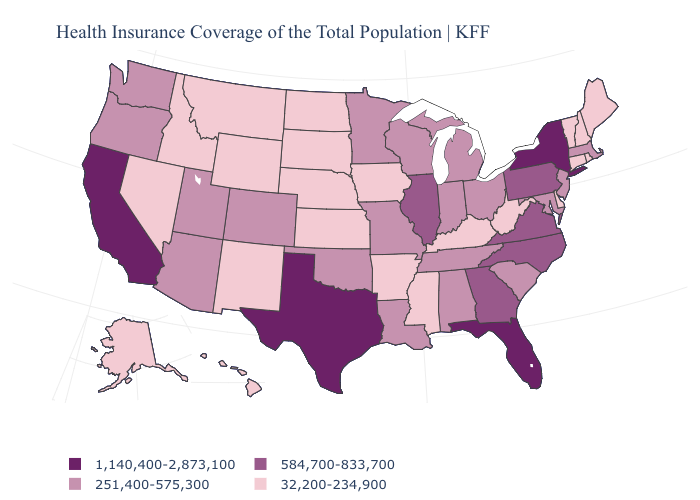Which states have the highest value in the USA?
Concise answer only. California, Florida, New York, Texas. Is the legend a continuous bar?
Answer briefly. No. Name the states that have a value in the range 1,140,400-2,873,100?
Short answer required. California, Florida, New York, Texas. Does the first symbol in the legend represent the smallest category?
Be succinct. No. Name the states that have a value in the range 1,140,400-2,873,100?
Keep it brief. California, Florida, New York, Texas. What is the lowest value in the West?
Quick response, please. 32,200-234,900. What is the lowest value in states that border Wisconsin?
Be succinct. 32,200-234,900. What is the value of Florida?
Keep it brief. 1,140,400-2,873,100. Does the map have missing data?
Short answer required. No. What is the value of Georgia?
Answer briefly. 584,700-833,700. What is the lowest value in states that border Washington?
Short answer required. 32,200-234,900. Name the states that have a value in the range 1,140,400-2,873,100?
Concise answer only. California, Florida, New York, Texas. Name the states that have a value in the range 32,200-234,900?
Be succinct. Alaska, Arkansas, Connecticut, Delaware, Hawaii, Idaho, Iowa, Kansas, Kentucky, Maine, Mississippi, Montana, Nebraska, Nevada, New Hampshire, New Mexico, North Dakota, Rhode Island, South Dakota, Vermont, West Virginia, Wyoming. How many symbols are there in the legend?
Answer briefly. 4. What is the value of Colorado?
Give a very brief answer. 251,400-575,300. 